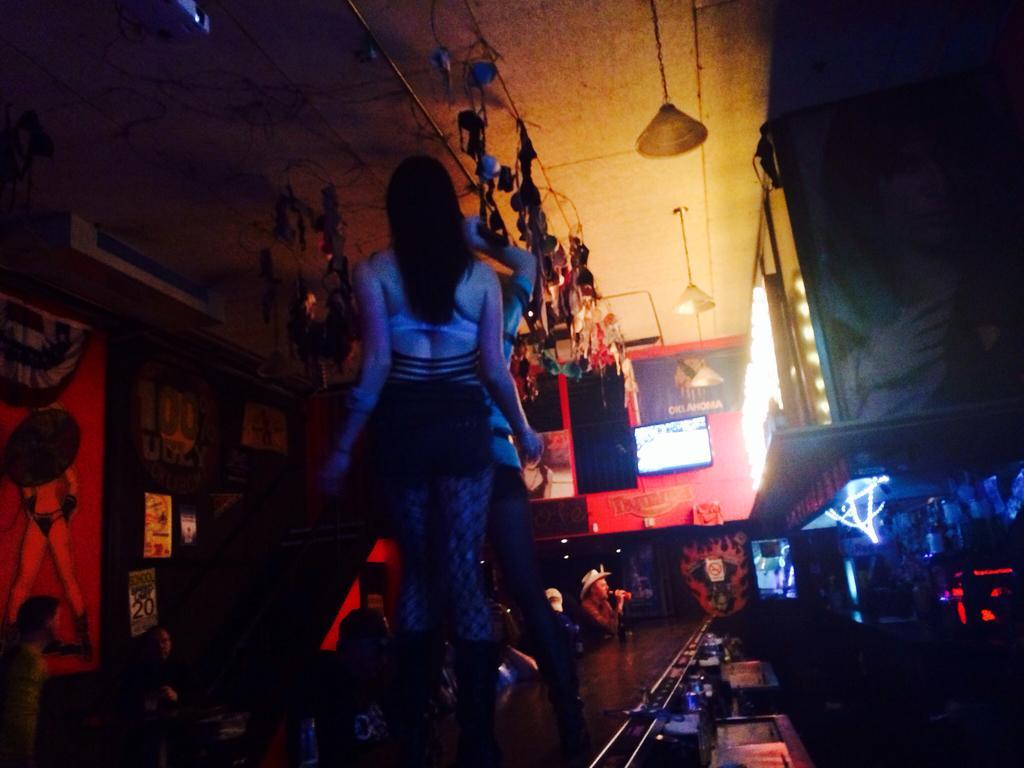Describe this image in one or two sentences. The picture is taken in a room. In the center of the picture there are two persons. On the right there are glasses, trays, lights and other objects. On the left there are people, posters and frames. In the center of the background there are people, desk and other objects. At the top there are some objects. 